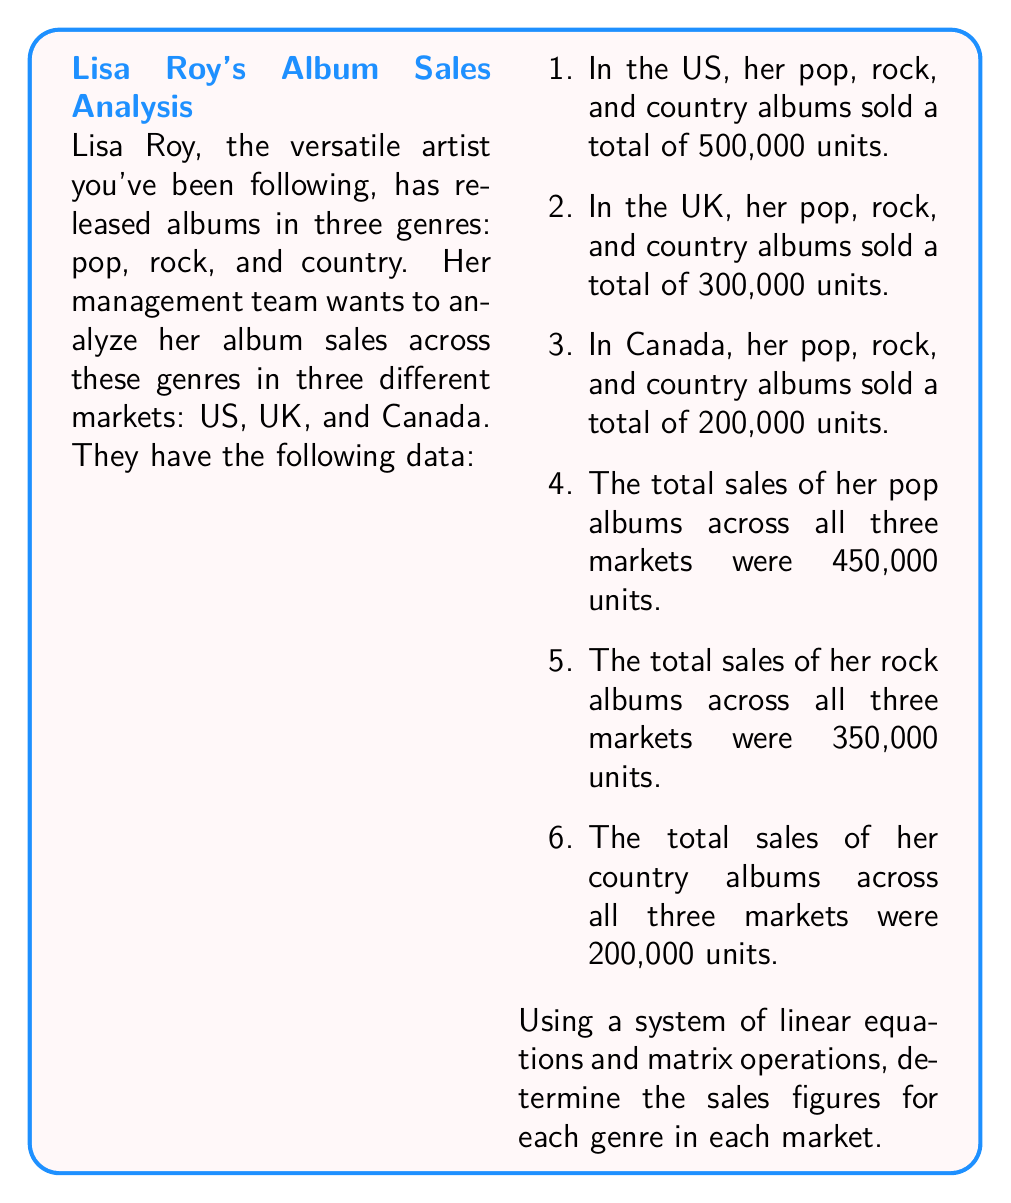Give your solution to this math problem. Let's approach this step-by-step using matrices:

1) First, let's define our variables:
   $x_1, x_2, x_3$: Pop album sales in US, UK, and Canada respectively
   $y_1, y_2, y_3$: Rock album sales in US, UK, and Canada respectively
   $z_1, z_2, z_3$: Country album sales in US, UK, and Canada respectively

2) Now, we can set up our system of equations:

   $$\begin{cases}
   x_1 + y_1 + z_1 = 500,000 \\
   x_2 + y_2 + z_2 = 300,000 \\
   x_3 + y_3 + z_3 = 200,000 \\
   x_1 + x_2 + x_3 = 450,000 \\
   y_1 + y_2 + y_3 = 350,000 \\
   z_1 + z_2 + z_3 = 200,000
   \end{cases}$$

3) We can represent this as a matrix equation $AX = B$, where:

   $$A = \begin{bmatrix}
   1 & 1 & 1 & 0 & 0 & 0 & 0 & 0 & 0 \\
   0 & 0 & 0 & 1 & 1 & 1 & 0 & 0 & 0 \\
   0 & 0 & 0 & 0 & 0 & 0 & 1 & 1 & 1 \\
   1 & 0 & 0 & 1 & 0 & 0 & 1 & 0 & 0 \\
   0 & 1 & 0 & 0 & 1 & 0 & 0 & 1 & 0 \\
   0 & 0 & 1 & 0 & 0 & 1 & 0 & 0 & 1
   \end{bmatrix}$$

   $$X = \begin{bmatrix}
   x_1 \\ x_2 \\ x_3 \\ y_1 \\ y_2 \\ y_3 \\ z_1 \\ z_2 \\ z_3
   \end{bmatrix}$$

   $$B = \begin{bmatrix}
   450,000 \\ 350,000 \\ 200,000 \\ 500,000 \\ 300,000 \\ 200,000
   \end{bmatrix}$$

4) To solve for X, we need to find $X = A^{-1}B$. However, A is not a square matrix, so we can't directly invert it.

5) Instead, we can use the Moore-Penrose pseudoinverse:
   $X = (A^T A)^{-1} A^T B$

6) Calculating this (which would typically be done with a computer or calculator), we get:

   $$X = \begin{bmatrix}
   250,000 \\ 150,000 \\ 50,000 \\ 150,000 \\ 100,000 \\ 100,000 \\ 100,000 \\ 50,000 \\ 50,000
   \end{bmatrix}$$

7) This gives us our solution:
   Pop: US (250,000), UK (150,000), Canada (50,000)
   Rock: US (150,000), UK (100,000), Canada (100,000)
   Country: US (100,000), UK (50,000), Canada (50,000)
Answer: Pop: US (250,000), UK (150,000), Canada (50,000); Rock: US (150,000), UK (100,000), Canada (100,000); Country: US (100,000), UK (50,000), Canada (50,000) 